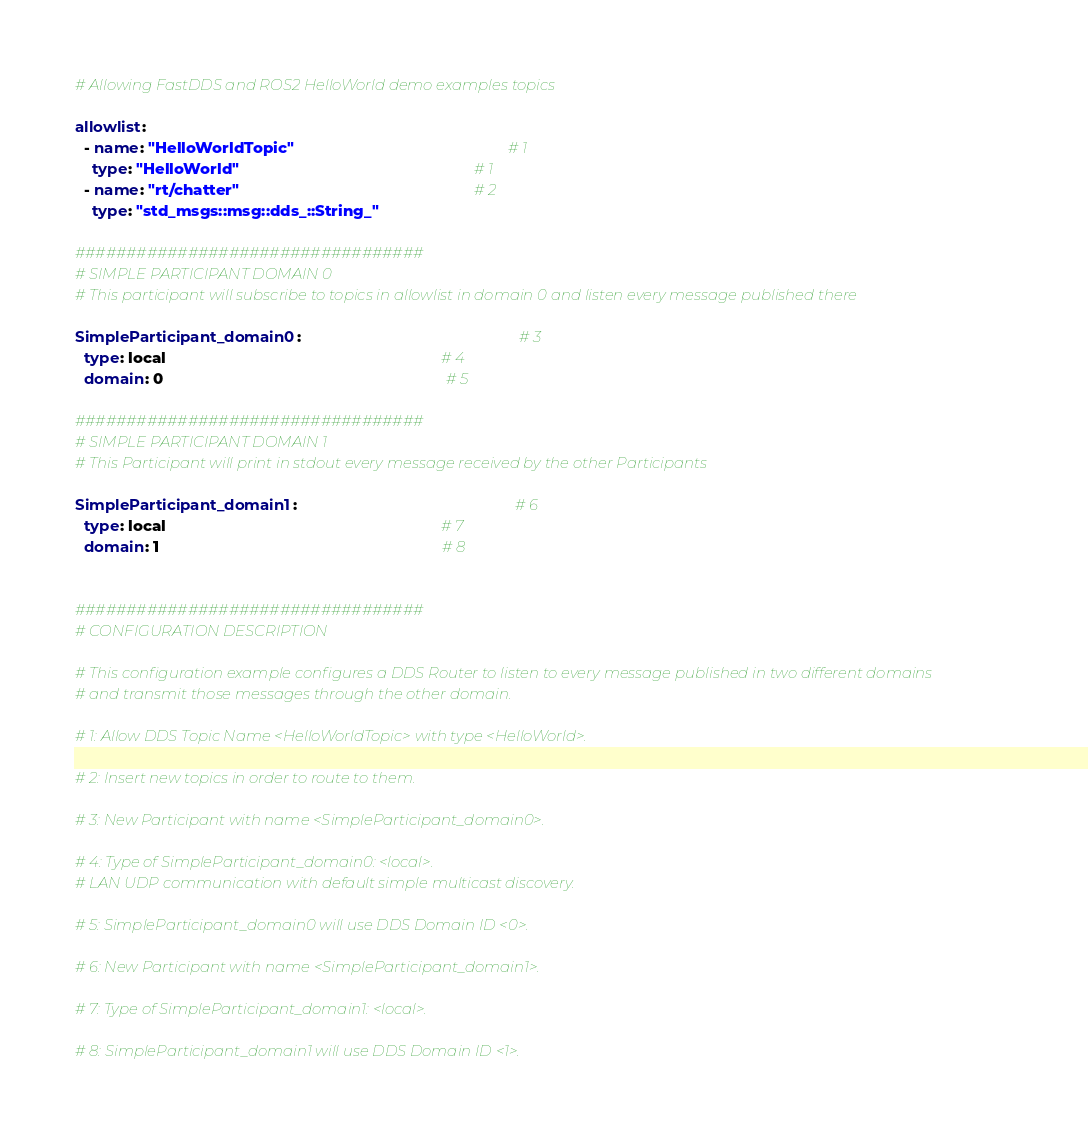<code> <loc_0><loc_0><loc_500><loc_500><_YAML_># Allowing FastDDS and ROS2 HelloWorld demo examples topics

allowlist:
  - name: "HelloWorldTopic"                                                 # 1
    type: "HelloWorld"                                                      # 1
  - name: "rt/chatter"                                                      # 2
    type: "std_msgs::msg::dds_::String_"

##################################
# SIMPLE PARTICIPANT DOMAIN 0
# This participant will subscribe to topics in allowlist in domain 0 and listen every message published there

SimpleParticipant_domain0:                                                  # 3
  type: local                                                               # 4
  domain: 0                                                                 # 5

##################################
# SIMPLE PARTICIPANT DOMAIN 1
# This Participant will print in stdout every message received by the other Participants

SimpleParticipant_domain1:                                                  # 6
  type: local                                                               # 7
  domain: 1                                                                 # 8


##################################
# CONFIGURATION DESCRIPTION

# This configuration example configures a DDS Router to listen to every message published in two different domains
# and transmit those messages through the other domain.

# 1: Allow DDS Topic Name <HelloWorldTopic> with type <HelloWorld>.

# 2: Insert new topics in order to route to them.

# 3: New Participant with name <SimpleParticipant_domain0>.

# 4: Type of SimpleParticipant_domain0: <local>.
# LAN UDP communication with default simple multicast discovery.

# 5: SimpleParticipant_domain0 will use DDS Domain ID <0>.

# 6: New Participant with name <SimpleParticipant_domain1>.

# 7: Type of SimpleParticipant_domain1: <local>.

# 8: SimpleParticipant_domain1 will use DDS Domain ID <1>.
</code> 